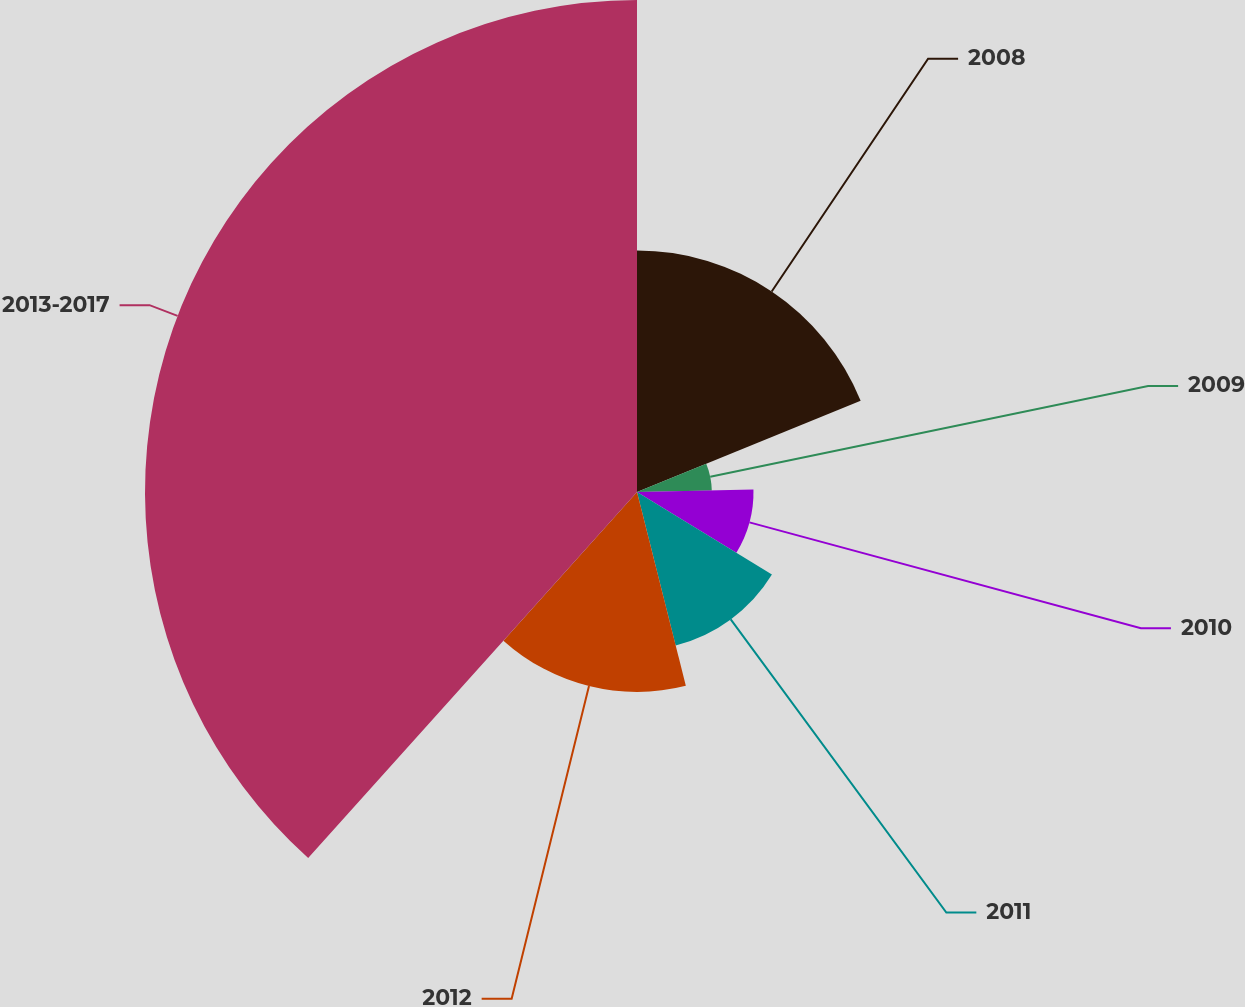Convert chart. <chart><loc_0><loc_0><loc_500><loc_500><pie_chart><fcel>2008<fcel>2009<fcel>2010<fcel>2011<fcel>2012<fcel>2013-2017<nl><fcel>18.83%<fcel>5.83%<fcel>9.08%<fcel>12.33%<fcel>15.58%<fcel>38.35%<nl></chart> 